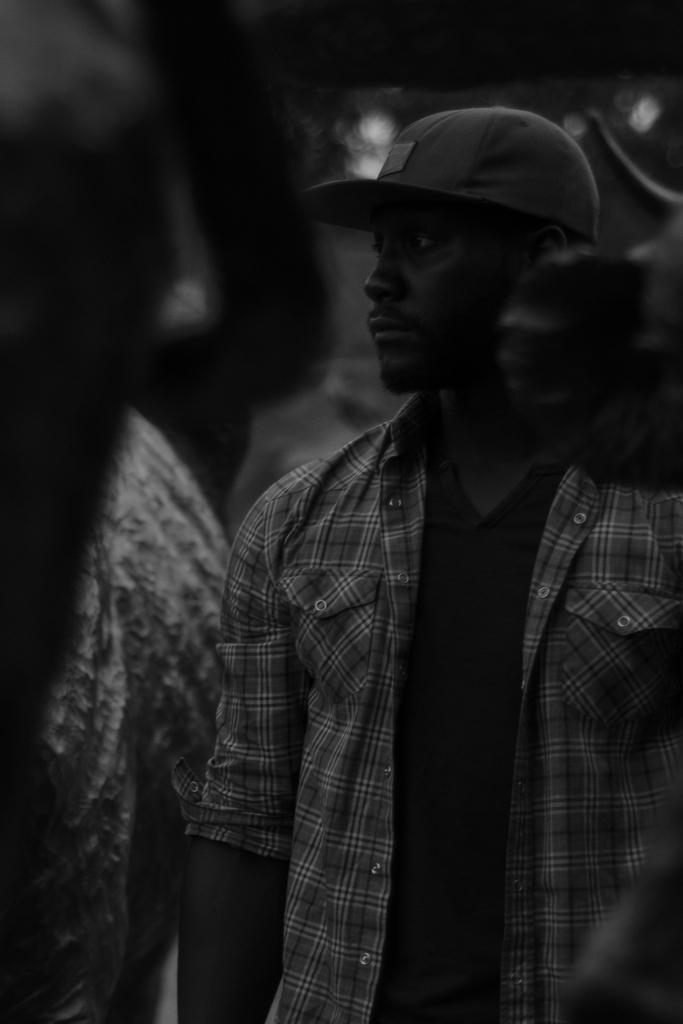How would you summarize this image in a sentence or two? In this image we can see few persons. The person in the foreground is wearing a cap. 